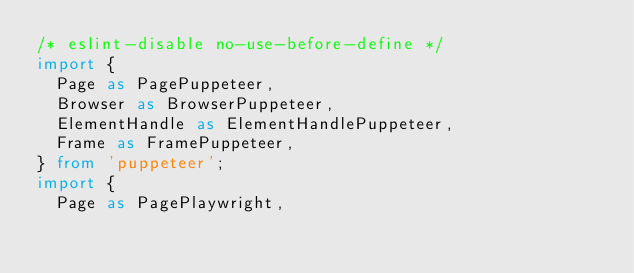Convert code to text. <code><loc_0><loc_0><loc_500><loc_500><_TypeScript_>/* eslint-disable no-use-before-define */
import {
  Page as PagePuppeteer,
  Browser as BrowserPuppeteer,
  ElementHandle as ElementHandlePuppeteer,
  Frame as FramePuppeteer,
} from 'puppeteer';
import {
  Page as PagePlaywright,</code> 